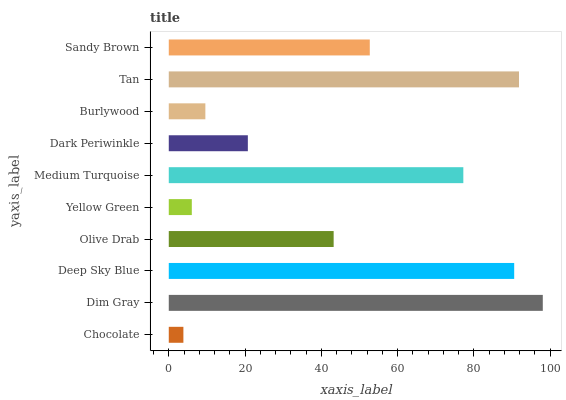Is Chocolate the minimum?
Answer yes or no. Yes. Is Dim Gray the maximum?
Answer yes or no. Yes. Is Deep Sky Blue the minimum?
Answer yes or no. No. Is Deep Sky Blue the maximum?
Answer yes or no. No. Is Dim Gray greater than Deep Sky Blue?
Answer yes or no. Yes. Is Deep Sky Blue less than Dim Gray?
Answer yes or no. Yes. Is Deep Sky Blue greater than Dim Gray?
Answer yes or no. No. Is Dim Gray less than Deep Sky Blue?
Answer yes or no. No. Is Sandy Brown the high median?
Answer yes or no. Yes. Is Olive Drab the low median?
Answer yes or no. Yes. Is Deep Sky Blue the high median?
Answer yes or no. No. Is Tan the low median?
Answer yes or no. No. 